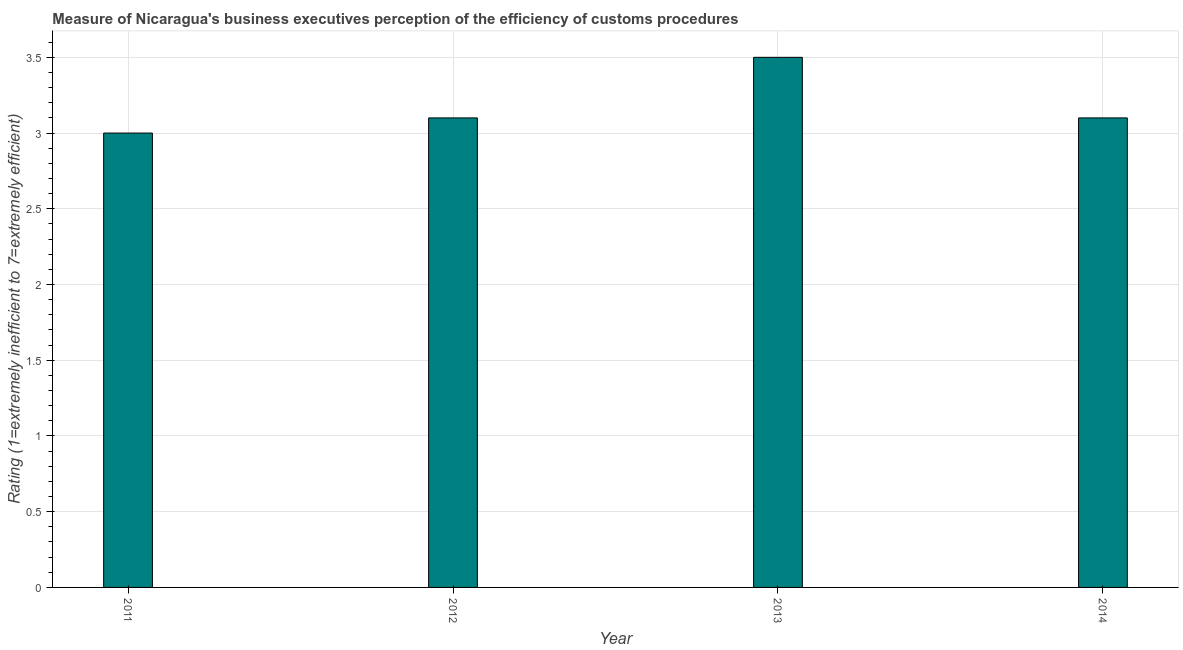Does the graph contain grids?
Provide a succinct answer. Yes. What is the title of the graph?
Keep it short and to the point. Measure of Nicaragua's business executives perception of the efficiency of customs procedures. What is the label or title of the X-axis?
Ensure brevity in your answer.  Year. What is the label or title of the Y-axis?
Offer a very short reply. Rating (1=extremely inefficient to 7=extremely efficient). Across all years, what is the maximum rating measuring burden of customs procedure?
Your answer should be compact. 3.5. In which year was the rating measuring burden of customs procedure maximum?
Offer a very short reply. 2013. What is the difference between the rating measuring burden of customs procedure in 2013 and 2014?
Provide a short and direct response. 0.4. What is the average rating measuring burden of customs procedure per year?
Offer a very short reply. 3.17. Do a majority of the years between 2014 and 2013 (inclusive) have rating measuring burden of customs procedure greater than 3.2 ?
Offer a terse response. No. What is the ratio of the rating measuring burden of customs procedure in 2012 to that in 2014?
Offer a terse response. 1. What is the difference between the highest and the lowest rating measuring burden of customs procedure?
Ensure brevity in your answer.  0.5. In how many years, is the rating measuring burden of customs procedure greater than the average rating measuring burden of customs procedure taken over all years?
Provide a short and direct response. 1. How many bars are there?
Give a very brief answer. 4. What is the difference between two consecutive major ticks on the Y-axis?
Ensure brevity in your answer.  0.5. What is the Rating (1=extremely inefficient to 7=extremely efficient) of 2012?
Offer a very short reply. 3.1. What is the difference between the Rating (1=extremely inefficient to 7=extremely efficient) in 2011 and 2012?
Your response must be concise. -0.1. What is the difference between the Rating (1=extremely inefficient to 7=extremely efficient) in 2012 and 2013?
Provide a succinct answer. -0.4. What is the ratio of the Rating (1=extremely inefficient to 7=extremely efficient) in 2011 to that in 2012?
Make the answer very short. 0.97. What is the ratio of the Rating (1=extremely inefficient to 7=extremely efficient) in 2011 to that in 2013?
Keep it short and to the point. 0.86. What is the ratio of the Rating (1=extremely inefficient to 7=extremely efficient) in 2011 to that in 2014?
Give a very brief answer. 0.97. What is the ratio of the Rating (1=extremely inefficient to 7=extremely efficient) in 2012 to that in 2013?
Your answer should be very brief. 0.89. What is the ratio of the Rating (1=extremely inefficient to 7=extremely efficient) in 2013 to that in 2014?
Your answer should be compact. 1.13. 